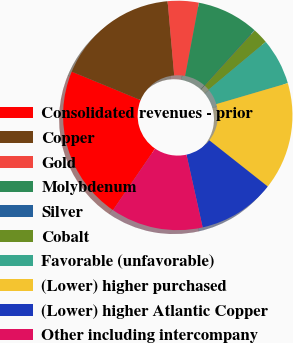Convert chart to OTSL. <chart><loc_0><loc_0><loc_500><loc_500><pie_chart><fcel>Consolidated revenues - prior<fcel>Copper<fcel>Gold<fcel>Molybdenum<fcel>Silver<fcel>Cobalt<fcel>Favorable (unfavorable)<fcel>(Lower) higher purchased<fcel>(Lower) higher Atlantic Copper<fcel>Other including intercompany<nl><fcel>21.69%<fcel>17.36%<fcel>4.37%<fcel>8.7%<fcel>0.05%<fcel>2.21%<fcel>6.54%<fcel>15.19%<fcel>10.87%<fcel>13.03%<nl></chart> 